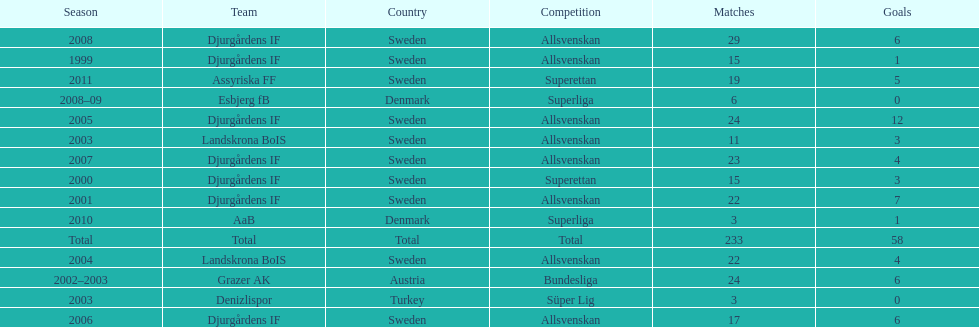How many teams had above 20 matches in the season? 6. 